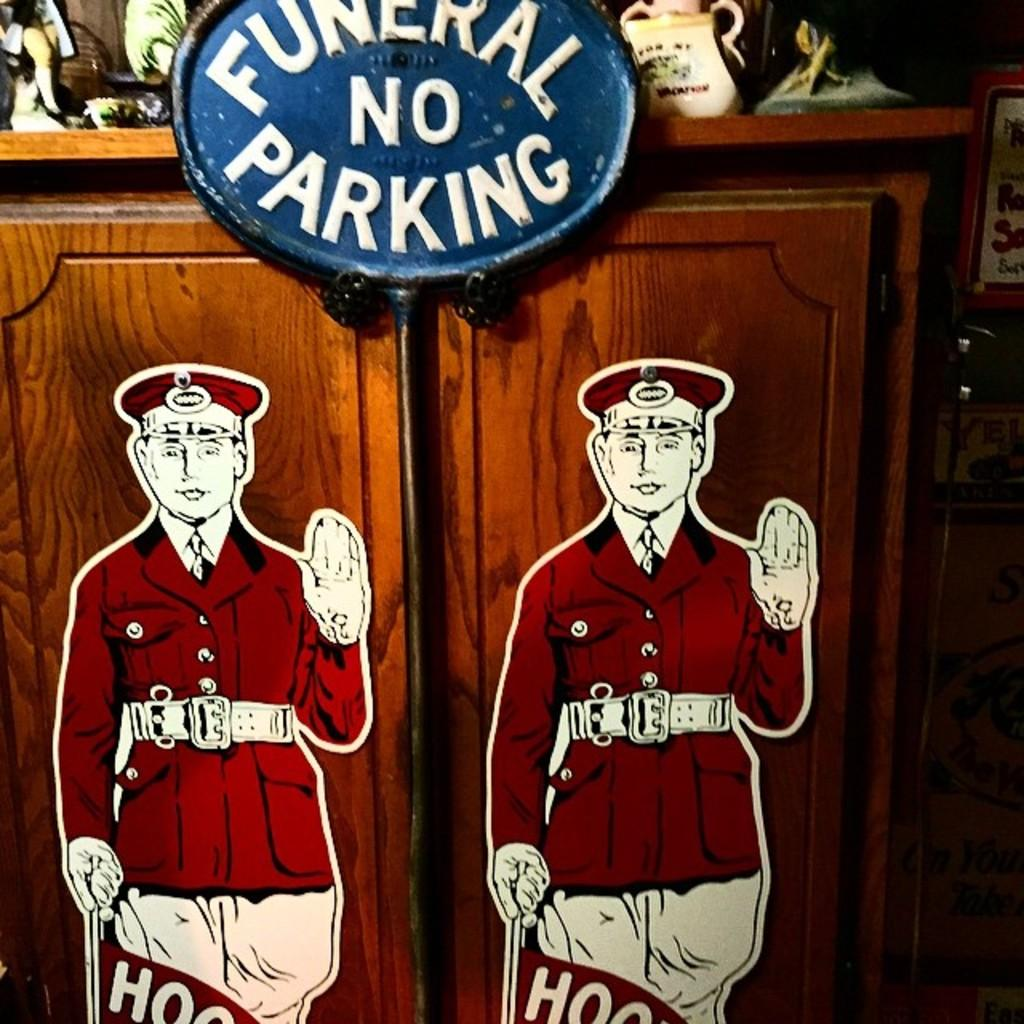<image>
Present a compact description of the photo's key features. An oval blue sign carries the message no parking. 